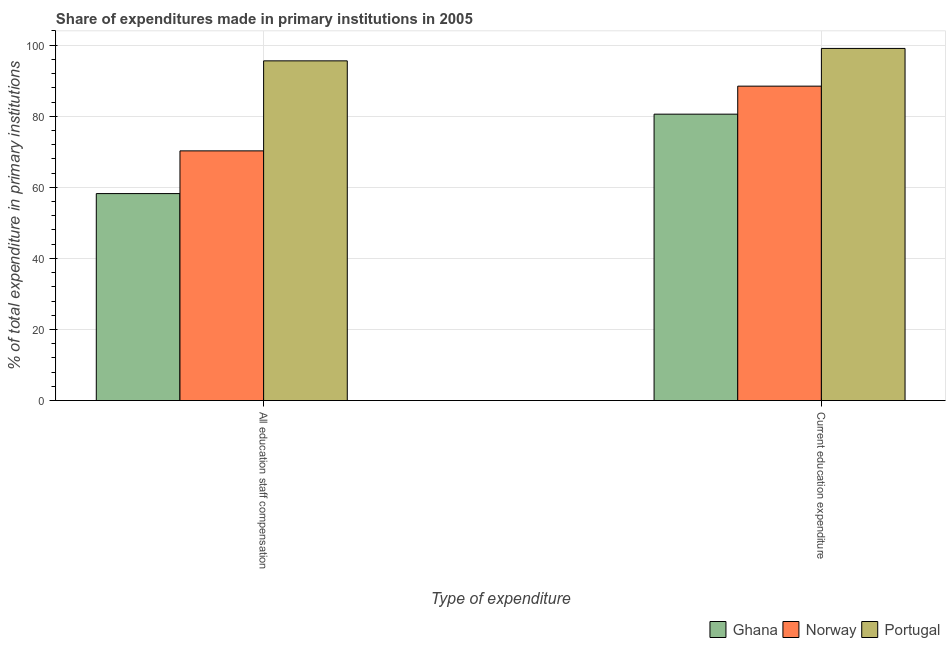How many different coloured bars are there?
Offer a very short reply. 3. How many groups of bars are there?
Make the answer very short. 2. Are the number of bars on each tick of the X-axis equal?
Make the answer very short. Yes. How many bars are there on the 1st tick from the right?
Your answer should be very brief. 3. What is the label of the 2nd group of bars from the left?
Ensure brevity in your answer.  Current education expenditure. What is the expenditure in staff compensation in Norway?
Provide a succinct answer. 70.27. Across all countries, what is the maximum expenditure in education?
Your answer should be compact. 99.09. Across all countries, what is the minimum expenditure in staff compensation?
Give a very brief answer. 58.25. In which country was the expenditure in education maximum?
Keep it short and to the point. Portugal. What is the total expenditure in education in the graph?
Your response must be concise. 268.17. What is the difference between the expenditure in education in Norway and that in Portugal?
Provide a succinct answer. -10.61. What is the difference between the expenditure in education in Ghana and the expenditure in staff compensation in Norway?
Your answer should be very brief. 10.33. What is the average expenditure in staff compensation per country?
Your answer should be very brief. 74.7. What is the difference between the expenditure in staff compensation and expenditure in education in Norway?
Offer a terse response. -18.21. What is the ratio of the expenditure in staff compensation in Ghana to that in Portugal?
Your response must be concise. 0.61. In how many countries, is the expenditure in staff compensation greater than the average expenditure in staff compensation taken over all countries?
Offer a terse response. 1. What does the 3rd bar from the left in Current education expenditure represents?
Your answer should be very brief. Portugal. Are all the bars in the graph horizontal?
Offer a very short reply. No. Does the graph contain grids?
Make the answer very short. Yes. Where does the legend appear in the graph?
Provide a succinct answer. Bottom right. How are the legend labels stacked?
Keep it short and to the point. Horizontal. What is the title of the graph?
Offer a terse response. Share of expenditures made in primary institutions in 2005. Does "Sub-Saharan Africa (developing only)" appear as one of the legend labels in the graph?
Your answer should be compact. No. What is the label or title of the X-axis?
Keep it short and to the point. Type of expenditure. What is the label or title of the Y-axis?
Make the answer very short. % of total expenditure in primary institutions. What is the % of total expenditure in primary institutions of Ghana in All education staff compensation?
Your response must be concise. 58.25. What is the % of total expenditure in primary institutions in Norway in All education staff compensation?
Your answer should be very brief. 70.27. What is the % of total expenditure in primary institutions in Portugal in All education staff compensation?
Offer a terse response. 95.6. What is the % of total expenditure in primary institutions in Ghana in Current education expenditure?
Offer a terse response. 80.6. What is the % of total expenditure in primary institutions in Norway in Current education expenditure?
Provide a succinct answer. 88.48. What is the % of total expenditure in primary institutions of Portugal in Current education expenditure?
Offer a very short reply. 99.09. Across all Type of expenditure, what is the maximum % of total expenditure in primary institutions in Ghana?
Offer a very short reply. 80.6. Across all Type of expenditure, what is the maximum % of total expenditure in primary institutions in Norway?
Give a very brief answer. 88.48. Across all Type of expenditure, what is the maximum % of total expenditure in primary institutions of Portugal?
Your answer should be compact. 99.09. Across all Type of expenditure, what is the minimum % of total expenditure in primary institutions of Ghana?
Make the answer very short. 58.25. Across all Type of expenditure, what is the minimum % of total expenditure in primary institutions in Norway?
Ensure brevity in your answer.  70.27. Across all Type of expenditure, what is the minimum % of total expenditure in primary institutions of Portugal?
Give a very brief answer. 95.6. What is the total % of total expenditure in primary institutions in Ghana in the graph?
Give a very brief answer. 138.84. What is the total % of total expenditure in primary institutions in Norway in the graph?
Offer a terse response. 158.75. What is the total % of total expenditure in primary institutions of Portugal in the graph?
Provide a succinct answer. 194.69. What is the difference between the % of total expenditure in primary institutions of Ghana in All education staff compensation and that in Current education expenditure?
Provide a succinct answer. -22.35. What is the difference between the % of total expenditure in primary institutions in Norway in All education staff compensation and that in Current education expenditure?
Your response must be concise. -18.21. What is the difference between the % of total expenditure in primary institutions of Portugal in All education staff compensation and that in Current education expenditure?
Give a very brief answer. -3.5. What is the difference between the % of total expenditure in primary institutions of Ghana in All education staff compensation and the % of total expenditure in primary institutions of Norway in Current education expenditure?
Provide a succinct answer. -30.23. What is the difference between the % of total expenditure in primary institutions of Ghana in All education staff compensation and the % of total expenditure in primary institutions of Portugal in Current education expenditure?
Your response must be concise. -40.84. What is the difference between the % of total expenditure in primary institutions of Norway in All education staff compensation and the % of total expenditure in primary institutions of Portugal in Current education expenditure?
Provide a short and direct response. -28.83. What is the average % of total expenditure in primary institutions in Ghana per Type of expenditure?
Keep it short and to the point. 69.42. What is the average % of total expenditure in primary institutions of Norway per Type of expenditure?
Provide a succinct answer. 79.37. What is the average % of total expenditure in primary institutions of Portugal per Type of expenditure?
Offer a very short reply. 97.34. What is the difference between the % of total expenditure in primary institutions of Ghana and % of total expenditure in primary institutions of Norway in All education staff compensation?
Make the answer very short. -12.02. What is the difference between the % of total expenditure in primary institutions of Ghana and % of total expenditure in primary institutions of Portugal in All education staff compensation?
Ensure brevity in your answer.  -37.35. What is the difference between the % of total expenditure in primary institutions in Norway and % of total expenditure in primary institutions in Portugal in All education staff compensation?
Provide a succinct answer. -25.33. What is the difference between the % of total expenditure in primary institutions of Ghana and % of total expenditure in primary institutions of Norway in Current education expenditure?
Provide a succinct answer. -7.88. What is the difference between the % of total expenditure in primary institutions in Ghana and % of total expenditure in primary institutions in Portugal in Current education expenditure?
Ensure brevity in your answer.  -18.5. What is the difference between the % of total expenditure in primary institutions of Norway and % of total expenditure in primary institutions of Portugal in Current education expenditure?
Give a very brief answer. -10.61. What is the ratio of the % of total expenditure in primary institutions in Ghana in All education staff compensation to that in Current education expenditure?
Make the answer very short. 0.72. What is the ratio of the % of total expenditure in primary institutions of Norway in All education staff compensation to that in Current education expenditure?
Your response must be concise. 0.79. What is the ratio of the % of total expenditure in primary institutions in Portugal in All education staff compensation to that in Current education expenditure?
Offer a terse response. 0.96. What is the difference between the highest and the second highest % of total expenditure in primary institutions in Ghana?
Keep it short and to the point. 22.35. What is the difference between the highest and the second highest % of total expenditure in primary institutions in Norway?
Ensure brevity in your answer.  18.21. What is the difference between the highest and the second highest % of total expenditure in primary institutions in Portugal?
Your answer should be compact. 3.5. What is the difference between the highest and the lowest % of total expenditure in primary institutions of Ghana?
Offer a terse response. 22.35. What is the difference between the highest and the lowest % of total expenditure in primary institutions in Norway?
Make the answer very short. 18.21. What is the difference between the highest and the lowest % of total expenditure in primary institutions in Portugal?
Provide a short and direct response. 3.5. 